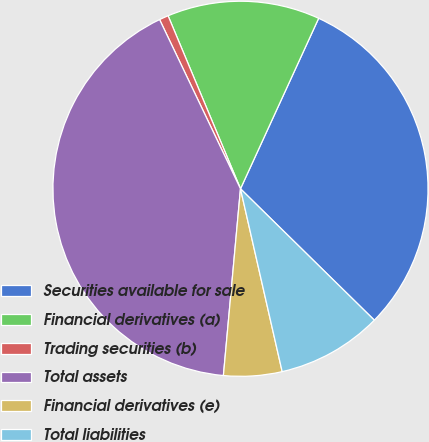Convert chart. <chart><loc_0><loc_0><loc_500><loc_500><pie_chart><fcel>Securities available for sale<fcel>Financial derivatives (a)<fcel>Trading securities (b)<fcel>Total assets<fcel>Financial derivatives (e)<fcel>Total liabilities<nl><fcel>30.51%<fcel>13.15%<fcel>0.79%<fcel>41.45%<fcel>5.02%<fcel>9.08%<nl></chart> 